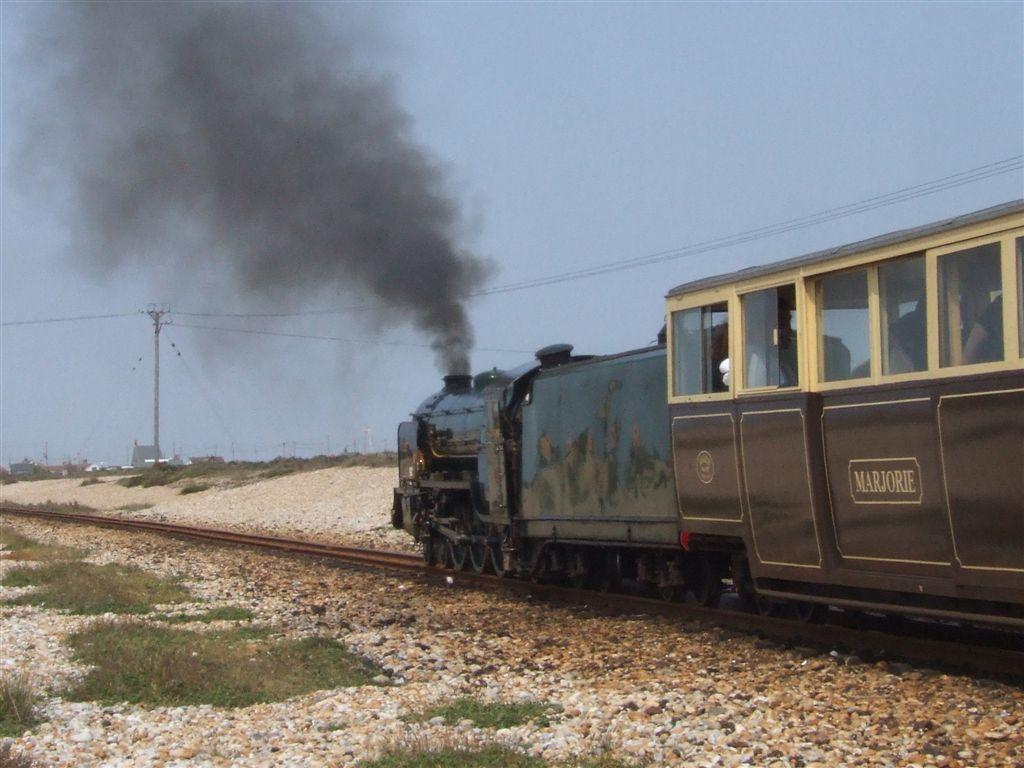How would you summarize this image in a sentence or two? In this image I can see railway tracks and on it I can see a train. I can also see grass, smoke, few wires, the sky and here I can see something is written. 